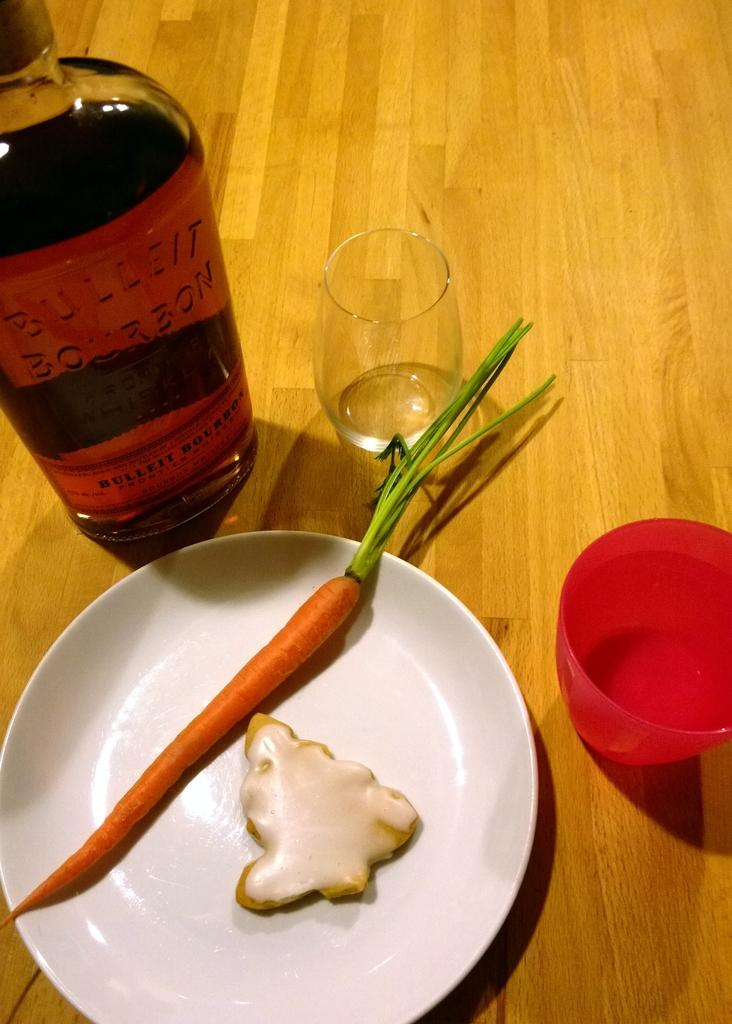<image>
Present a compact description of the photo's key features. A bottle of bourbon next to a plate which has a carrot on it. 